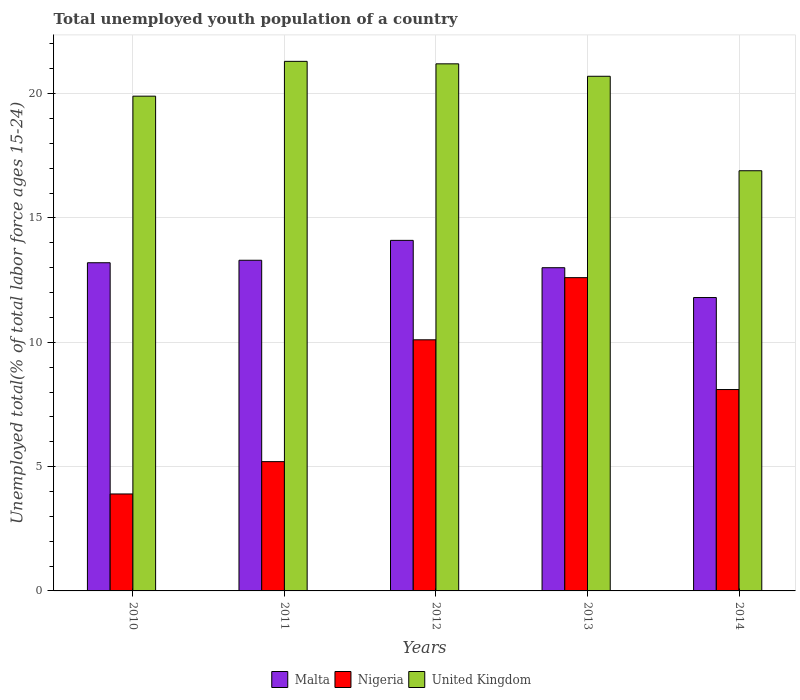Are the number of bars on each tick of the X-axis equal?
Make the answer very short. Yes. How many bars are there on the 3rd tick from the left?
Offer a very short reply. 3. In how many cases, is the number of bars for a given year not equal to the number of legend labels?
Provide a succinct answer. 0. What is the percentage of total unemployed youth population of a country in Nigeria in 2011?
Provide a short and direct response. 5.2. Across all years, what is the maximum percentage of total unemployed youth population of a country in United Kingdom?
Give a very brief answer. 21.3. Across all years, what is the minimum percentage of total unemployed youth population of a country in Nigeria?
Give a very brief answer. 3.9. In which year was the percentage of total unemployed youth population of a country in Nigeria minimum?
Your response must be concise. 2010. What is the total percentage of total unemployed youth population of a country in United Kingdom in the graph?
Make the answer very short. 100. What is the difference between the percentage of total unemployed youth population of a country in Nigeria in 2010 and that in 2011?
Give a very brief answer. -1.3. What is the difference between the percentage of total unemployed youth population of a country in Nigeria in 2011 and the percentage of total unemployed youth population of a country in United Kingdom in 2014?
Your answer should be very brief. -11.7. What is the average percentage of total unemployed youth population of a country in Malta per year?
Ensure brevity in your answer.  13.08. In the year 2011, what is the difference between the percentage of total unemployed youth population of a country in Nigeria and percentage of total unemployed youth population of a country in United Kingdom?
Keep it short and to the point. -16.1. What is the ratio of the percentage of total unemployed youth population of a country in United Kingdom in 2012 to that in 2013?
Your response must be concise. 1.02. Is the percentage of total unemployed youth population of a country in Nigeria in 2012 less than that in 2013?
Ensure brevity in your answer.  Yes. Is the difference between the percentage of total unemployed youth population of a country in Nigeria in 2013 and 2014 greater than the difference between the percentage of total unemployed youth population of a country in United Kingdom in 2013 and 2014?
Your response must be concise. Yes. What is the difference between the highest and the second highest percentage of total unemployed youth population of a country in Malta?
Keep it short and to the point. 0.8. What is the difference between the highest and the lowest percentage of total unemployed youth population of a country in United Kingdom?
Your answer should be very brief. 4.4. What does the 1st bar from the left in 2010 represents?
Provide a succinct answer. Malta. What does the 2nd bar from the right in 2012 represents?
Ensure brevity in your answer.  Nigeria. Is it the case that in every year, the sum of the percentage of total unemployed youth population of a country in Malta and percentage of total unemployed youth population of a country in United Kingdom is greater than the percentage of total unemployed youth population of a country in Nigeria?
Your response must be concise. Yes. How many bars are there?
Make the answer very short. 15. How many years are there in the graph?
Provide a succinct answer. 5. Does the graph contain grids?
Your answer should be compact. Yes. Where does the legend appear in the graph?
Provide a succinct answer. Bottom center. What is the title of the graph?
Provide a short and direct response. Total unemployed youth population of a country. Does "East Asia (developing only)" appear as one of the legend labels in the graph?
Keep it short and to the point. No. What is the label or title of the Y-axis?
Your response must be concise. Unemployed total(% of total labor force ages 15-24). What is the Unemployed total(% of total labor force ages 15-24) of Malta in 2010?
Your answer should be compact. 13.2. What is the Unemployed total(% of total labor force ages 15-24) of Nigeria in 2010?
Your response must be concise. 3.9. What is the Unemployed total(% of total labor force ages 15-24) of United Kingdom in 2010?
Provide a short and direct response. 19.9. What is the Unemployed total(% of total labor force ages 15-24) in Malta in 2011?
Keep it short and to the point. 13.3. What is the Unemployed total(% of total labor force ages 15-24) in Nigeria in 2011?
Ensure brevity in your answer.  5.2. What is the Unemployed total(% of total labor force ages 15-24) of United Kingdom in 2011?
Give a very brief answer. 21.3. What is the Unemployed total(% of total labor force ages 15-24) of Malta in 2012?
Provide a short and direct response. 14.1. What is the Unemployed total(% of total labor force ages 15-24) of Nigeria in 2012?
Offer a terse response. 10.1. What is the Unemployed total(% of total labor force ages 15-24) of United Kingdom in 2012?
Provide a succinct answer. 21.2. What is the Unemployed total(% of total labor force ages 15-24) in Malta in 2013?
Make the answer very short. 13. What is the Unemployed total(% of total labor force ages 15-24) of Nigeria in 2013?
Make the answer very short. 12.6. What is the Unemployed total(% of total labor force ages 15-24) of United Kingdom in 2013?
Offer a very short reply. 20.7. What is the Unemployed total(% of total labor force ages 15-24) of Malta in 2014?
Your response must be concise. 11.8. What is the Unemployed total(% of total labor force ages 15-24) of Nigeria in 2014?
Give a very brief answer. 8.1. What is the Unemployed total(% of total labor force ages 15-24) of United Kingdom in 2014?
Your answer should be compact. 16.9. Across all years, what is the maximum Unemployed total(% of total labor force ages 15-24) in Malta?
Your answer should be very brief. 14.1. Across all years, what is the maximum Unemployed total(% of total labor force ages 15-24) of Nigeria?
Keep it short and to the point. 12.6. Across all years, what is the maximum Unemployed total(% of total labor force ages 15-24) of United Kingdom?
Your answer should be very brief. 21.3. Across all years, what is the minimum Unemployed total(% of total labor force ages 15-24) of Malta?
Your answer should be compact. 11.8. Across all years, what is the minimum Unemployed total(% of total labor force ages 15-24) in Nigeria?
Provide a succinct answer. 3.9. Across all years, what is the minimum Unemployed total(% of total labor force ages 15-24) in United Kingdom?
Ensure brevity in your answer.  16.9. What is the total Unemployed total(% of total labor force ages 15-24) in Malta in the graph?
Ensure brevity in your answer.  65.4. What is the total Unemployed total(% of total labor force ages 15-24) in Nigeria in the graph?
Offer a very short reply. 39.9. What is the difference between the Unemployed total(% of total labor force ages 15-24) in Malta in 2010 and that in 2011?
Keep it short and to the point. -0.1. What is the difference between the Unemployed total(% of total labor force ages 15-24) of United Kingdom in 2010 and that in 2012?
Offer a very short reply. -1.3. What is the difference between the Unemployed total(% of total labor force ages 15-24) of Nigeria in 2010 and that in 2013?
Give a very brief answer. -8.7. What is the difference between the Unemployed total(% of total labor force ages 15-24) in United Kingdom in 2010 and that in 2013?
Your response must be concise. -0.8. What is the difference between the Unemployed total(% of total labor force ages 15-24) of Nigeria in 2010 and that in 2014?
Your response must be concise. -4.2. What is the difference between the Unemployed total(% of total labor force ages 15-24) in United Kingdom in 2010 and that in 2014?
Keep it short and to the point. 3. What is the difference between the Unemployed total(% of total labor force ages 15-24) of United Kingdom in 2011 and that in 2012?
Offer a very short reply. 0.1. What is the difference between the Unemployed total(% of total labor force ages 15-24) of United Kingdom in 2012 and that in 2013?
Ensure brevity in your answer.  0.5. What is the difference between the Unemployed total(% of total labor force ages 15-24) in Malta in 2013 and that in 2014?
Provide a short and direct response. 1.2. What is the difference between the Unemployed total(% of total labor force ages 15-24) in Nigeria in 2013 and that in 2014?
Give a very brief answer. 4.5. What is the difference between the Unemployed total(% of total labor force ages 15-24) in United Kingdom in 2013 and that in 2014?
Keep it short and to the point. 3.8. What is the difference between the Unemployed total(% of total labor force ages 15-24) in Nigeria in 2010 and the Unemployed total(% of total labor force ages 15-24) in United Kingdom in 2011?
Offer a terse response. -17.4. What is the difference between the Unemployed total(% of total labor force ages 15-24) in Malta in 2010 and the Unemployed total(% of total labor force ages 15-24) in Nigeria in 2012?
Your answer should be compact. 3.1. What is the difference between the Unemployed total(% of total labor force ages 15-24) in Malta in 2010 and the Unemployed total(% of total labor force ages 15-24) in United Kingdom in 2012?
Your answer should be compact. -8. What is the difference between the Unemployed total(% of total labor force ages 15-24) in Nigeria in 2010 and the Unemployed total(% of total labor force ages 15-24) in United Kingdom in 2012?
Your answer should be compact. -17.3. What is the difference between the Unemployed total(% of total labor force ages 15-24) of Malta in 2010 and the Unemployed total(% of total labor force ages 15-24) of Nigeria in 2013?
Ensure brevity in your answer.  0.6. What is the difference between the Unemployed total(% of total labor force ages 15-24) of Nigeria in 2010 and the Unemployed total(% of total labor force ages 15-24) of United Kingdom in 2013?
Your answer should be very brief. -16.8. What is the difference between the Unemployed total(% of total labor force ages 15-24) of Nigeria in 2011 and the Unemployed total(% of total labor force ages 15-24) of United Kingdom in 2012?
Your response must be concise. -16. What is the difference between the Unemployed total(% of total labor force ages 15-24) in Malta in 2011 and the Unemployed total(% of total labor force ages 15-24) in United Kingdom in 2013?
Your answer should be very brief. -7.4. What is the difference between the Unemployed total(% of total labor force ages 15-24) of Nigeria in 2011 and the Unemployed total(% of total labor force ages 15-24) of United Kingdom in 2013?
Ensure brevity in your answer.  -15.5. What is the difference between the Unemployed total(% of total labor force ages 15-24) in Malta in 2011 and the Unemployed total(% of total labor force ages 15-24) in Nigeria in 2014?
Provide a short and direct response. 5.2. What is the difference between the Unemployed total(% of total labor force ages 15-24) of Malta in 2012 and the Unemployed total(% of total labor force ages 15-24) of United Kingdom in 2013?
Ensure brevity in your answer.  -6.6. What is the difference between the Unemployed total(% of total labor force ages 15-24) in Nigeria in 2012 and the Unemployed total(% of total labor force ages 15-24) in United Kingdom in 2013?
Make the answer very short. -10.6. What is the difference between the Unemployed total(% of total labor force ages 15-24) of Malta in 2012 and the Unemployed total(% of total labor force ages 15-24) of United Kingdom in 2014?
Provide a succinct answer. -2.8. What is the difference between the Unemployed total(% of total labor force ages 15-24) in Malta in 2013 and the Unemployed total(% of total labor force ages 15-24) in United Kingdom in 2014?
Your answer should be compact. -3.9. What is the average Unemployed total(% of total labor force ages 15-24) of Malta per year?
Your answer should be compact. 13.08. What is the average Unemployed total(% of total labor force ages 15-24) in Nigeria per year?
Ensure brevity in your answer.  7.98. What is the average Unemployed total(% of total labor force ages 15-24) of United Kingdom per year?
Give a very brief answer. 20. In the year 2011, what is the difference between the Unemployed total(% of total labor force ages 15-24) in Malta and Unemployed total(% of total labor force ages 15-24) in Nigeria?
Keep it short and to the point. 8.1. In the year 2011, what is the difference between the Unemployed total(% of total labor force ages 15-24) in Nigeria and Unemployed total(% of total labor force ages 15-24) in United Kingdom?
Provide a short and direct response. -16.1. In the year 2012, what is the difference between the Unemployed total(% of total labor force ages 15-24) of Nigeria and Unemployed total(% of total labor force ages 15-24) of United Kingdom?
Ensure brevity in your answer.  -11.1. In the year 2013, what is the difference between the Unemployed total(% of total labor force ages 15-24) in Malta and Unemployed total(% of total labor force ages 15-24) in Nigeria?
Make the answer very short. 0.4. In the year 2014, what is the difference between the Unemployed total(% of total labor force ages 15-24) in Malta and Unemployed total(% of total labor force ages 15-24) in Nigeria?
Your answer should be very brief. 3.7. In the year 2014, what is the difference between the Unemployed total(% of total labor force ages 15-24) of Malta and Unemployed total(% of total labor force ages 15-24) of United Kingdom?
Ensure brevity in your answer.  -5.1. What is the ratio of the Unemployed total(% of total labor force ages 15-24) in Malta in 2010 to that in 2011?
Give a very brief answer. 0.99. What is the ratio of the Unemployed total(% of total labor force ages 15-24) of Nigeria in 2010 to that in 2011?
Offer a very short reply. 0.75. What is the ratio of the Unemployed total(% of total labor force ages 15-24) of United Kingdom in 2010 to that in 2011?
Offer a terse response. 0.93. What is the ratio of the Unemployed total(% of total labor force ages 15-24) of Malta in 2010 to that in 2012?
Ensure brevity in your answer.  0.94. What is the ratio of the Unemployed total(% of total labor force ages 15-24) in Nigeria in 2010 to that in 2012?
Provide a short and direct response. 0.39. What is the ratio of the Unemployed total(% of total labor force ages 15-24) in United Kingdom in 2010 to that in 2012?
Make the answer very short. 0.94. What is the ratio of the Unemployed total(% of total labor force ages 15-24) of Malta in 2010 to that in 2013?
Keep it short and to the point. 1.02. What is the ratio of the Unemployed total(% of total labor force ages 15-24) in Nigeria in 2010 to that in 2013?
Your answer should be compact. 0.31. What is the ratio of the Unemployed total(% of total labor force ages 15-24) of United Kingdom in 2010 to that in 2013?
Ensure brevity in your answer.  0.96. What is the ratio of the Unemployed total(% of total labor force ages 15-24) in Malta in 2010 to that in 2014?
Your response must be concise. 1.12. What is the ratio of the Unemployed total(% of total labor force ages 15-24) in Nigeria in 2010 to that in 2014?
Keep it short and to the point. 0.48. What is the ratio of the Unemployed total(% of total labor force ages 15-24) of United Kingdom in 2010 to that in 2014?
Keep it short and to the point. 1.18. What is the ratio of the Unemployed total(% of total labor force ages 15-24) in Malta in 2011 to that in 2012?
Keep it short and to the point. 0.94. What is the ratio of the Unemployed total(% of total labor force ages 15-24) in Nigeria in 2011 to that in 2012?
Your answer should be very brief. 0.51. What is the ratio of the Unemployed total(% of total labor force ages 15-24) in Malta in 2011 to that in 2013?
Provide a succinct answer. 1.02. What is the ratio of the Unemployed total(% of total labor force ages 15-24) in Nigeria in 2011 to that in 2013?
Keep it short and to the point. 0.41. What is the ratio of the Unemployed total(% of total labor force ages 15-24) of United Kingdom in 2011 to that in 2013?
Provide a succinct answer. 1.03. What is the ratio of the Unemployed total(% of total labor force ages 15-24) in Malta in 2011 to that in 2014?
Your answer should be compact. 1.13. What is the ratio of the Unemployed total(% of total labor force ages 15-24) of Nigeria in 2011 to that in 2014?
Keep it short and to the point. 0.64. What is the ratio of the Unemployed total(% of total labor force ages 15-24) of United Kingdom in 2011 to that in 2014?
Your answer should be compact. 1.26. What is the ratio of the Unemployed total(% of total labor force ages 15-24) of Malta in 2012 to that in 2013?
Your answer should be very brief. 1.08. What is the ratio of the Unemployed total(% of total labor force ages 15-24) in Nigeria in 2012 to that in 2013?
Your answer should be very brief. 0.8. What is the ratio of the Unemployed total(% of total labor force ages 15-24) of United Kingdom in 2012 to that in 2013?
Your answer should be compact. 1.02. What is the ratio of the Unemployed total(% of total labor force ages 15-24) of Malta in 2012 to that in 2014?
Your answer should be very brief. 1.19. What is the ratio of the Unemployed total(% of total labor force ages 15-24) in Nigeria in 2012 to that in 2014?
Provide a succinct answer. 1.25. What is the ratio of the Unemployed total(% of total labor force ages 15-24) of United Kingdom in 2012 to that in 2014?
Make the answer very short. 1.25. What is the ratio of the Unemployed total(% of total labor force ages 15-24) in Malta in 2013 to that in 2014?
Your answer should be very brief. 1.1. What is the ratio of the Unemployed total(% of total labor force ages 15-24) in Nigeria in 2013 to that in 2014?
Your answer should be very brief. 1.56. What is the ratio of the Unemployed total(% of total labor force ages 15-24) of United Kingdom in 2013 to that in 2014?
Provide a succinct answer. 1.22. What is the difference between the highest and the second highest Unemployed total(% of total labor force ages 15-24) of Malta?
Offer a terse response. 0.8. What is the difference between the highest and the second highest Unemployed total(% of total labor force ages 15-24) of Nigeria?
Your answer should be compact. 2.5. What is the difference between the highest and the lowest Unemployed total(% of total labor force ages 15-24) of United Kingdom?
Offer a very short reply. 4.4. 